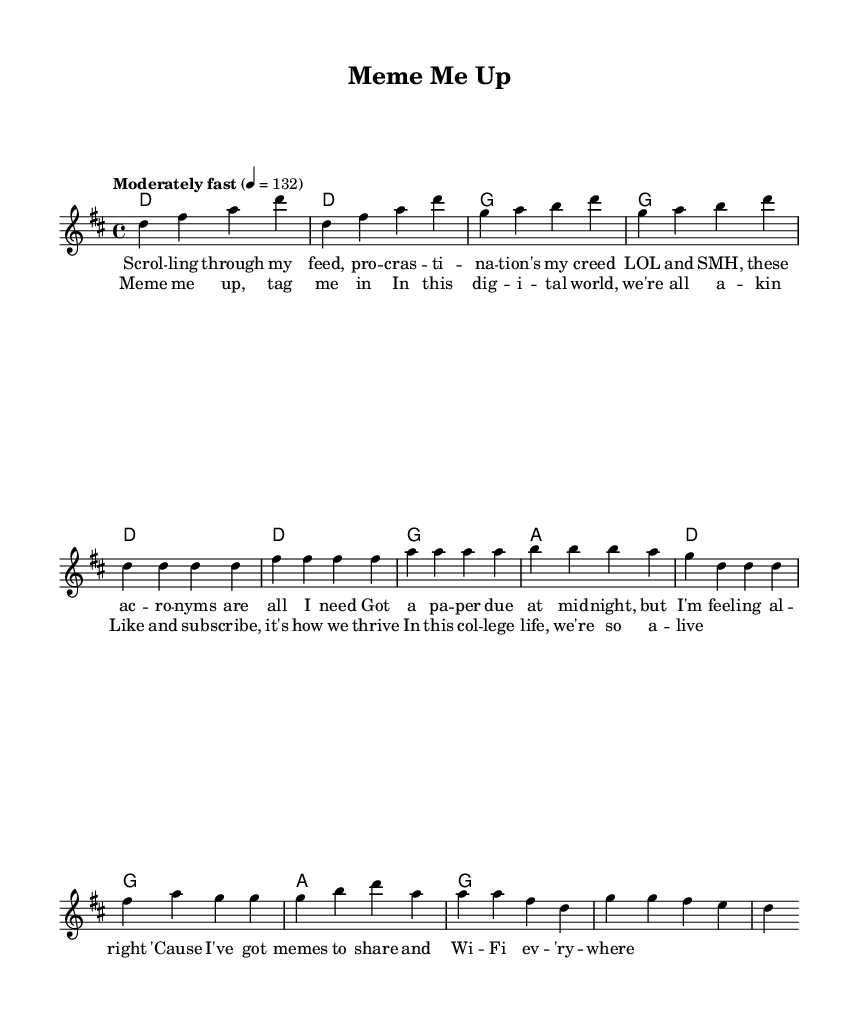What is the key signature of this music? The key signature is D major, which has two sharps (F# and C#). This is indicated at the beginning of the staff where the sharps are placed.
Answer: D major What is the time signature of this piece? The time signature is 4/4, commonly indicated at the beginning of the score next to the key signature. This means there are four beats per measure and the quarter note gets one beat.
Answer: 4/4 What is the tempo marking for the piece? The tempo marking is "Moderately fast" at a quarter note equals 132 beats per minute, which is stated at the beginning of the score before the melody begins.
Answer: Moderately fast How many measures are in the verse section? The verse has eight measures, determined by counting each bar in the section marked "Verse" in the melody part.
Answer: 8 What is the first lyric line of the chorus? The first lyric line of the chorus is "Meme me up, tag me in", which can be found in the section marked "Chorus" in the lyrics part of the sheet music.
Answer: Meme me up, tag me in What chord is played during the intro? The chord played during the intro is D major, as shown in the harmonies section at the beginning, where it specifies the chords to be played with each measure.
Answer: D Which lyric follows "pro--cras--ti--na--tion's my creed"? The lyric that follows is "LOL and SMH, these ac--ro--nyms are all I need", which can be found in the verse section of the lyrics.
Answer: LOL and SMH, these ac--ro--nyms are all I need 